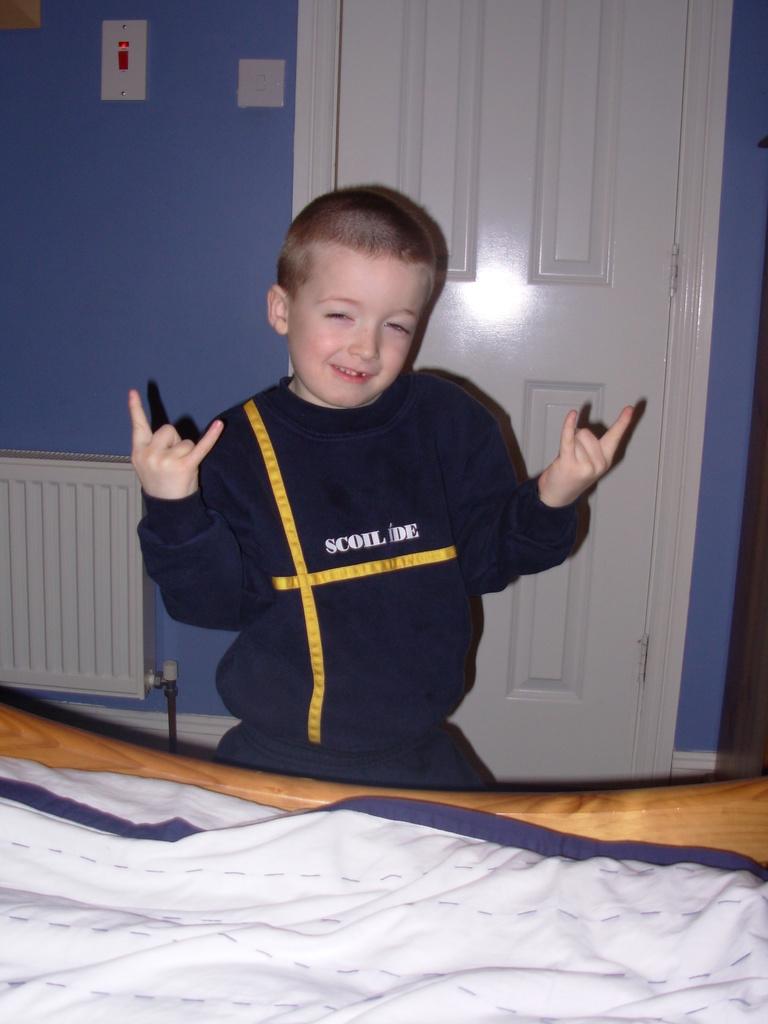What is the first word on the boy's shirt?
Offer a terse response. Scoil. What is the second word on his shirt?
Make the answer very short. Ide. 